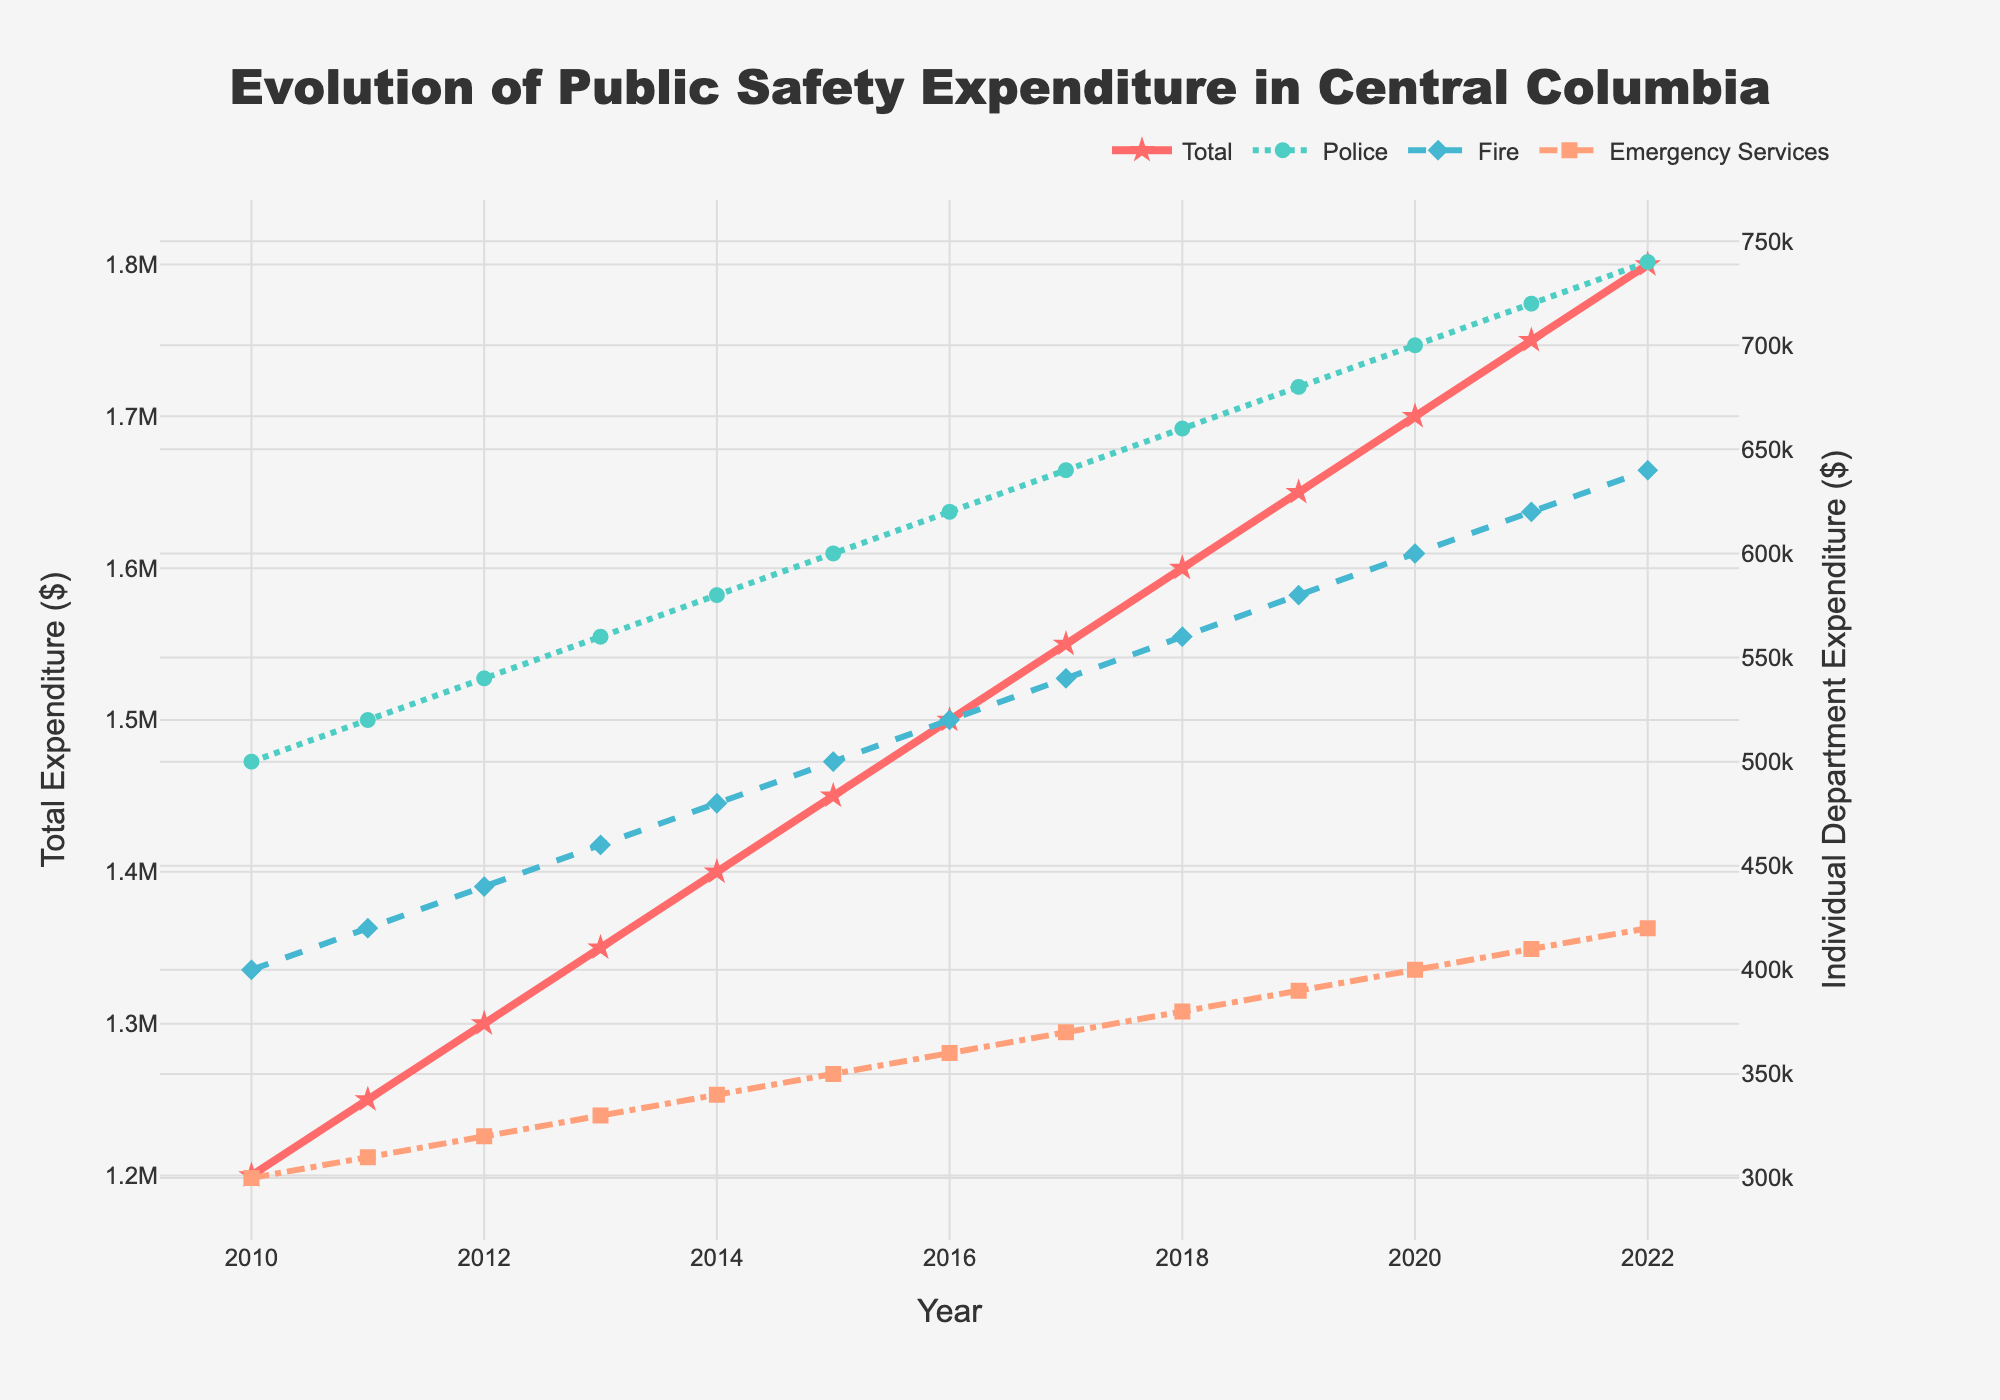what is the title of the plot? The title of the plot is present at the top of the figure, typically in a larger and bold font for emphasis. For this figure, it reads "Evolution of Public Safety Expenditure in Central Columbia".
Answer: Evolution of Public Safety Expenditure in Central Columbia which color represents the police expenditure? The police expenditure line is represented by a unique color in the plot to distinguish it from other categories. According to the data, it is represented by the color '#4ECDC4', which is a shade of teal or green-blue.
Answer: teal how did the total public safety expenditure change from 2010 to 2022? To find this, examine the values on the y-axis for the Total Public Safety Expenditure at the starting year, 2010, which is $1,200,000, and the ending year, 2022, which is $1,800,000. The change is calculated by subtracting the 2010 value from the 2022 value.
Answer: $600,000 what is the pattern of emergency services expenditure over the years? The Emergency Services Expenditure is represented by a line with a specific color and symbol. By observing this line from 2010 to 2022, it can be noted that the expenditure increases each year gradually.
Answer: steadily increasing by how much did fire expenditure increase from 2011 to 2015? Notice the Fire Expenditure values for 2011 and 2015, which are $420,000 and $500,000 respectively. To find the increase, subtract the 2011 value from the 2015 value. $500,000 - $420,000
Answer: $80,000 in which year did police expenditure reach $700,000? By examining the Police Expenditure line and finding where it crosses the $700,000 mark on the y-axis, it can be identified that this value is reached in the year 2020.
Answer: 2020 is the trend for total public safety expenditure linear or exponential? By observing the Total Public Safety Expenditure line, we see a consistent upward increment each year which indicates a linear trend rather than an exponential rate of increase.
Answer: linear compare the rate of increase in police expenditure and fire expenditure from 2010 to 2022 First, find the difference in both expenditures from 2010 to 2022 for police and fire: $740,000 - $500,000 for police and $640,000 - $400,000 for fire. Police increase is $240,000 and fire is $240,000; both increase equally.
Answer: same rate which department had the smallest expenditure every year? By comparing the lines in the plot for Police, Fire, and Emergency Services, we can see that the Emergency Services Expenditure line is always the lowest among the three in every year.
Answer: emergency services 